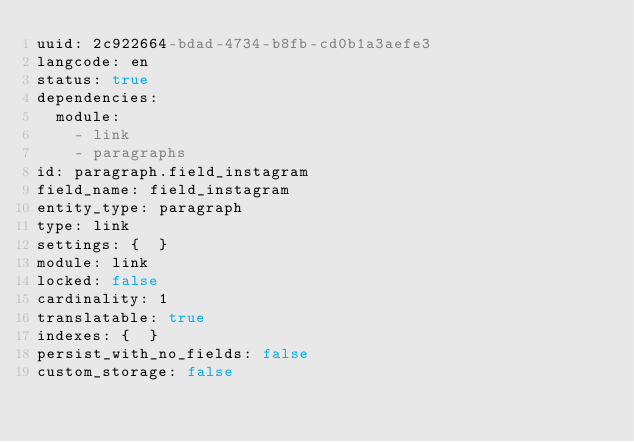Convert code to text. <code><loc_0><loc_0><loc_500><loc_500><_YAML_>uuid: 2c922664-bdad-4734-b8fb-cd0b1a3aefe3
langcode: en
status: true
dependencies:
  module:
    - link
    - paragraphs
id: paragraph.field_instagram
field_name: field_instagram
entity_type: paragraph
type: link
settings: {  }
module: link
locked: false
cardinality: 1
translatable: true
indexes: {  }
persist_with_no_fields: false
custom_storage: false
</code> 